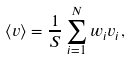<formula> <loc_0><loc_0><loc_500><loc_500>\langle v \rangle = \frac { 1 } { S } \sum _ { i = 1 } ^ { N } w _ { i } v _ { i } ,</formula> 